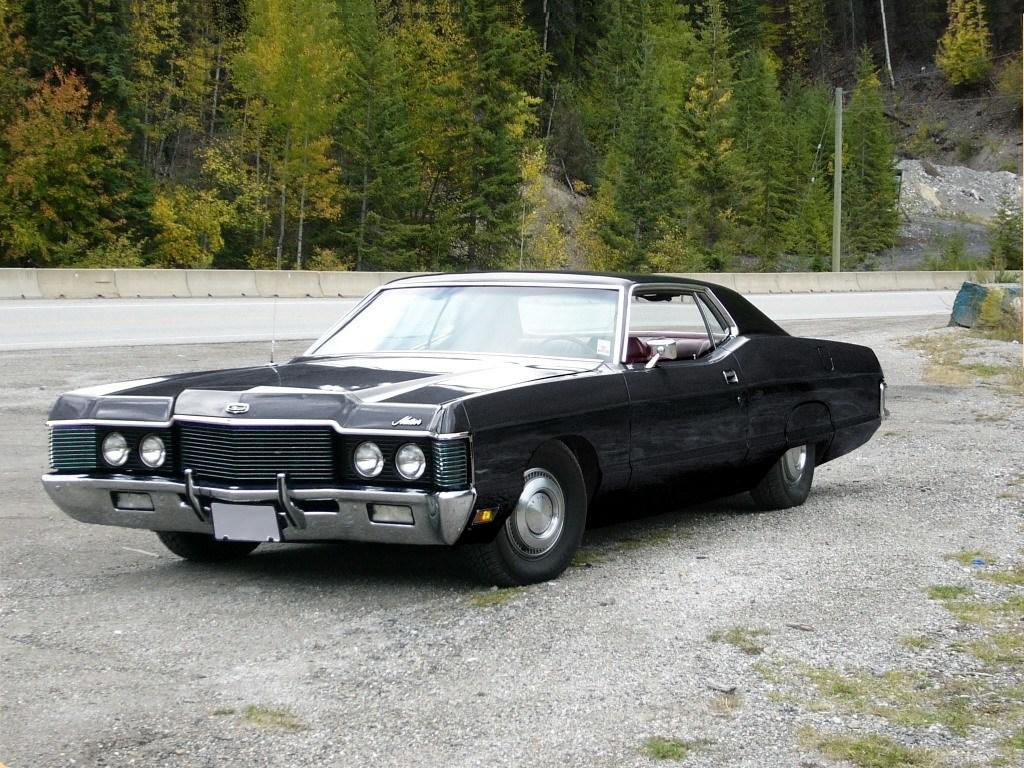What type of vehicle can be seen on the road in the image? There is a car visible on the road in the image. What natural elements are visible at the top of the image? Trees and poles are visible at the top of the image. What structure is located in the middle of the image? There is a wall in the middle of the image. What type of disease is being treated in the image? There is no indication of any disease or medical treatment in the image. What type of glue is being used to attach the trees to the poles in the image? There is no glue or attachment process visible in the image; the trees and poles are separate elements. 